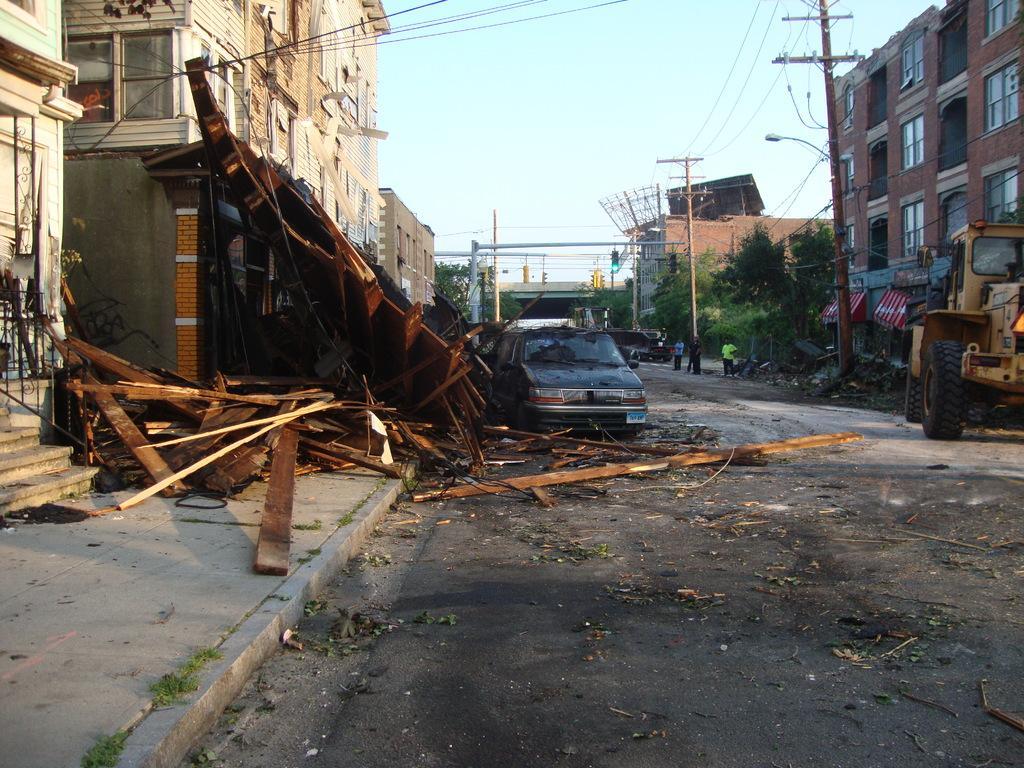Please provide a concise description of this image. In this image we can see vehicles on the road. On the left side of the image, we can see buildings, pavement and wood pieces. On the right side of the image, we can see electricity pole, wires and light, trees and buildings. We can see the sky at the top of the image. It seems like flyover in the middle of the image. 